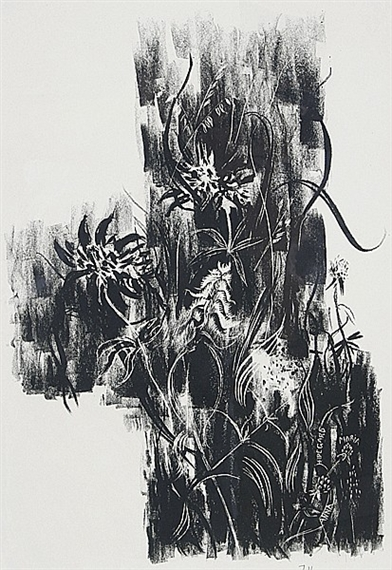Can you explain how the choice of black and white influences the viewer's perception of this artwork? The choice of black and white in this artwork intensifies the visual impact and focuses the viewer's attention on the graphic elements like texture and form without the distraction of color. This dichotomy not only enhances the dramatic effect but also adds a timeless quality to the piece. The sharp contrast often heightens the emotional response, making the abstract forms more poignant and stirring, as viewers may find their own meanings and feelings reflected in the stark interplay of light and shadow. 